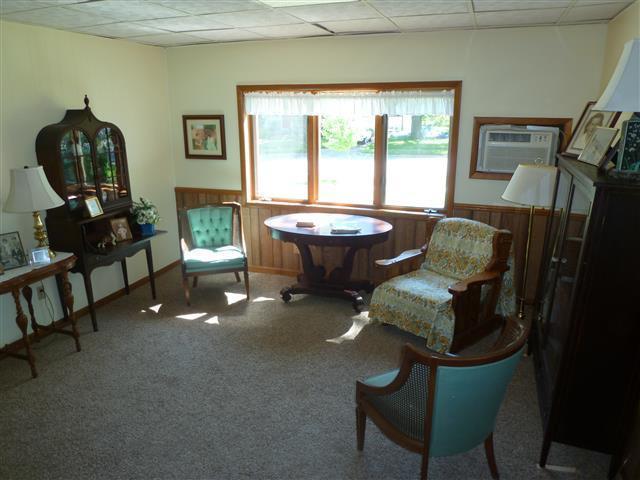How many chairs are visible?
Give a very brief answer. 3. How many men are in this picture?
Give a very brief answer. 0. 